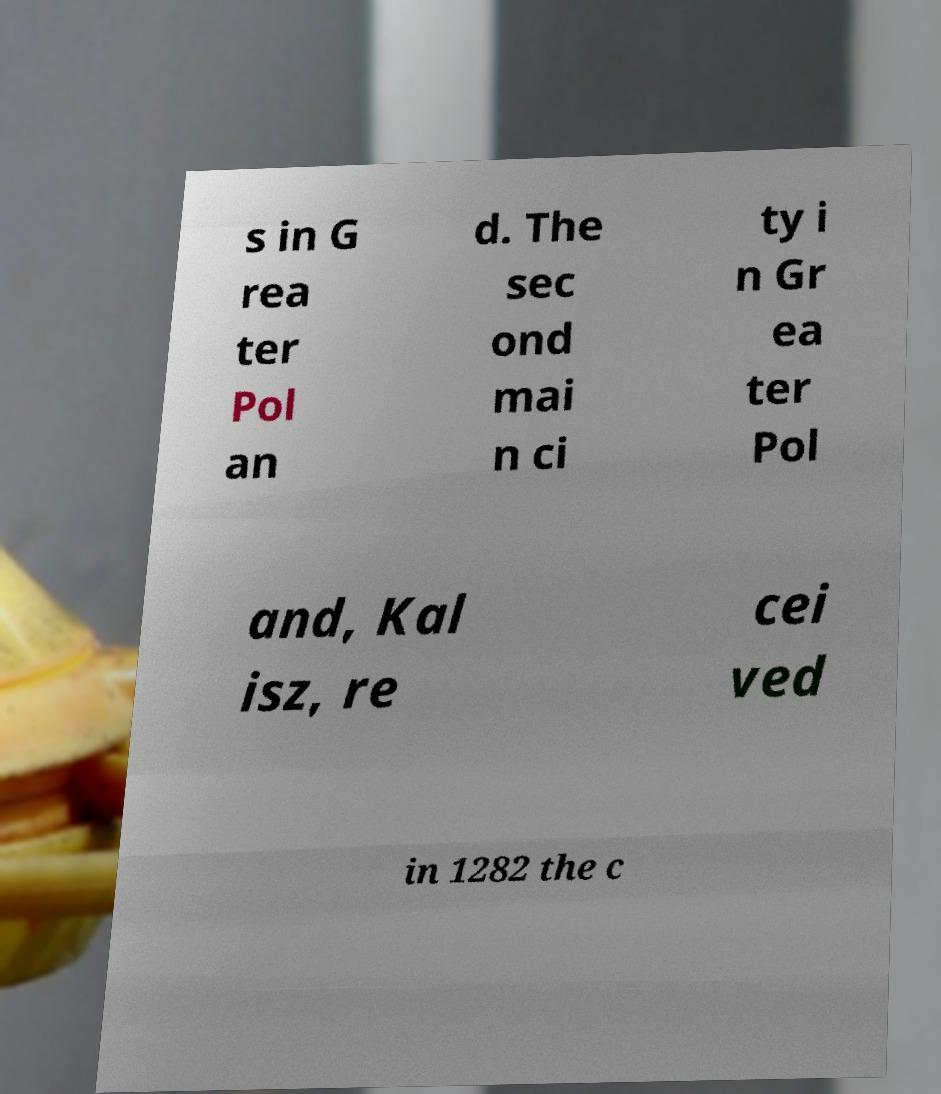Can you accurately transcribe the text from the provided image for me? s in G rea ter Pol an d. The sec ond mai n ci ty i n Gr ea ter Pol and, Kal isz, re cei ved in 1282 the c 